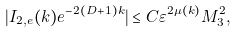Convert formula to latex. <formula><loc_0><loc_0><loc_500><loc_500>| I _ { 2 , e } ( k ) e ^ { - 2 ( D + 1 ) k } | \leq C \varepsilon ^ { 2 \mu ( k ) } M _ { 3 } ^ { 2 } ,</formula> 